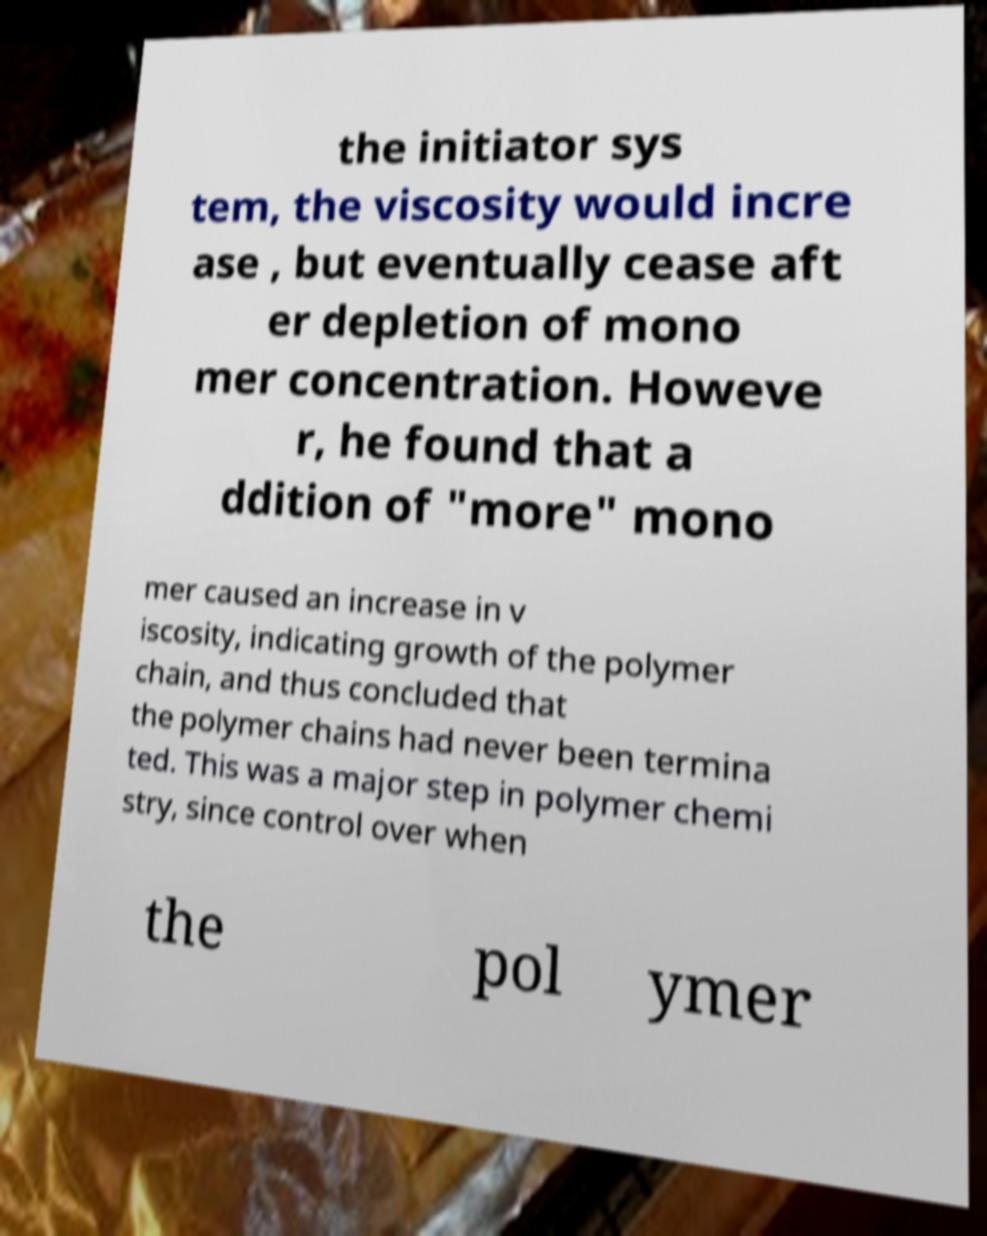I need the written content from this picture converted into text. Can you do that? the initiator sys tem, the viscosity would incre ase , but eventually cease aft er depletion of mono mer concentration. Howeve r, he found that a ddition of "more" mono mer caused an increase in v iscosity, indicating growth of the polymer chain, and thus concluded that the polymer chains had never been termina ted. This was a major step in polymer chemi stry, since control over when the pol ymer 